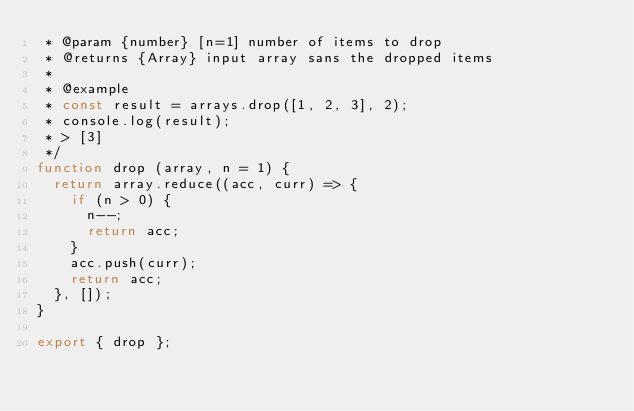Convert code to text. <code><loc_0><loc_0><loc_500><loc_500><_JavaScript_> * @param {number} [n=1] number of items to drop
 * @returns {Array} input array sans the dropped items
 *
 * @example
 * const result = arrays.drop([1, 2, 3], 2);
 * console.log(result);
 * > [3]
 */
function drop (array, n = 1) {
  return array.reduce((acc, curr) => {
    if (n > 0) {
      n--;
      return acc;
    }
    acc.push(curr);
    return acc;
  }, []);
}

export { drop };
</code> 